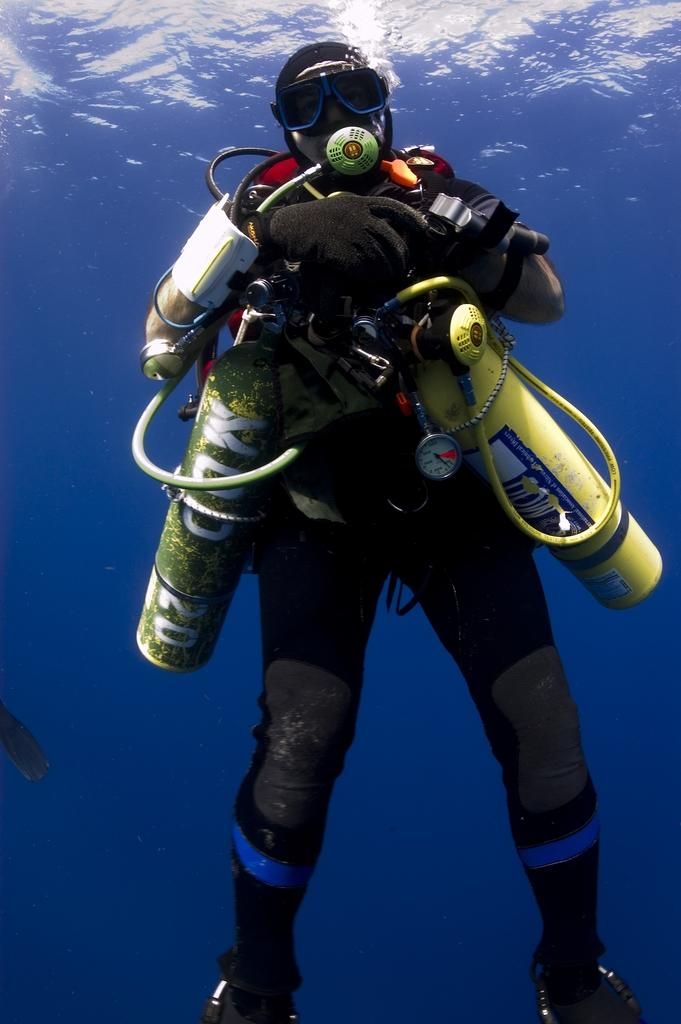What is the main subject of the image? The main subject of the image is a human. What is the location of the human in the image? The human is under the water. How is the human positioned in the image? The human is located in the middle of the image. What type of alarm is the human using underwater in the image? There is no alarm present in the image, as the human is underwater and not using any alarm. 